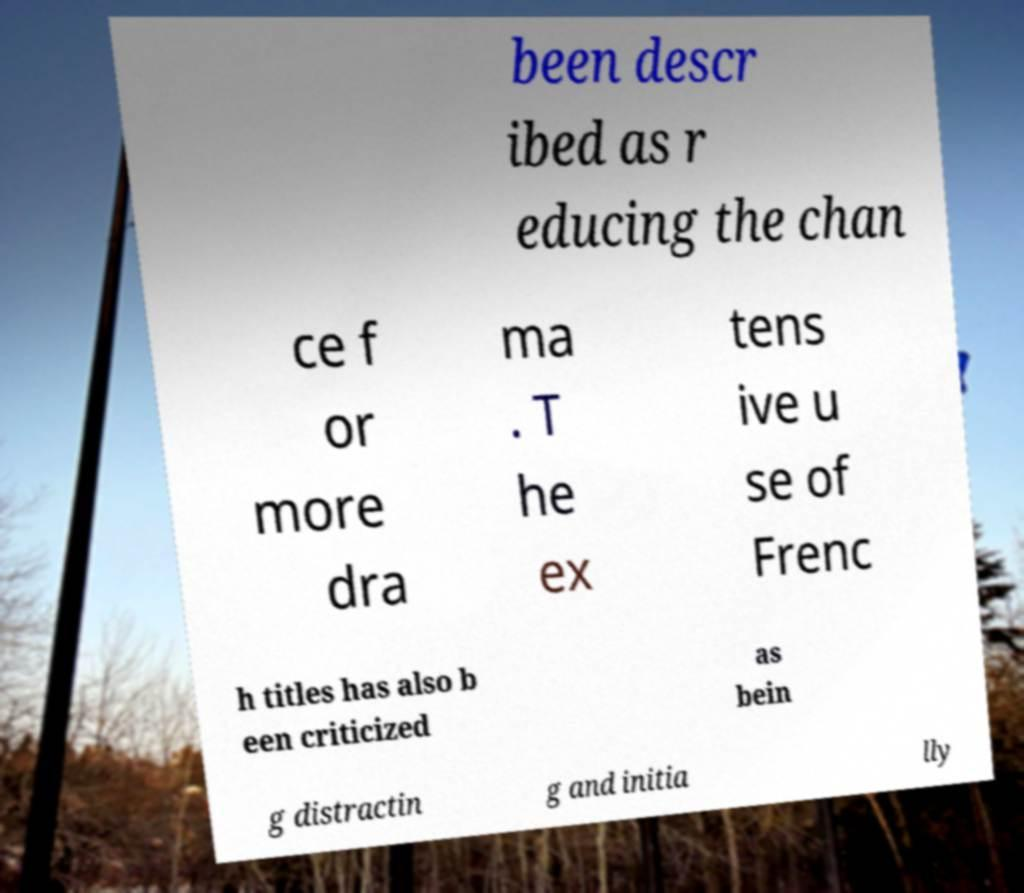For documentation purposes, I need the text within this image transcribed. Could you provide that? been descr ibed as r educing the chan ce f or more dra ma . T he ex tens ive u se of Frenc h titles has also b een criticized as bein g distractin g and initia lly 